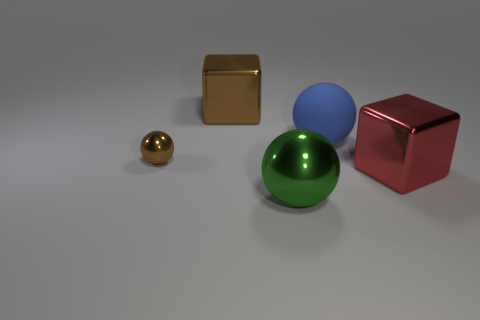There is a metallic cube that is to the left of the blue object; is its size the same as the green shiny sphere?
Ensure brevity in your answer.  Yes. Is there a big metal block that has the same color as the small metallic ball?
Keep it short and to the point. Yes. How many things are either large shiny cubes behind the small brown sphere or big shiny things in front of the big red metal thing?
Provide a succinct answer. 2. What is the material of the big object that is the same color as the tiny shiny object?
Provide a short and direct response. Metal. Is the number of big blue matte balls that are behind the small ball less than the number of big blue matte balls to the right of the red metallic thing?
Give a very brief answer. No. Is the material of the brown sphere the same as the big brown block?
Keep it short and to the point. Yes. There is a metallic object that is both in front of the blue object and to the left of the large green metallic thing; how big is it?
Keep it short and to the point. Small. The red metal thing that is the same size as the blue rubber object is what shape?
Keep it short and to the point. Cube. There is a block behind the shiny sphere behind the metal thing right of the big metal sphere; what is it made of?
Provide a succinct answer. Metal. Is the shape of the big thing that is behind the blue object the same as the large object in front of the big red shiny object?
Your answer should be very brief. No. 